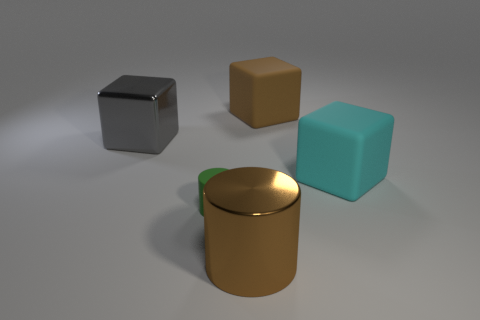Add 1 big rubber cubes. How many objects exist? 6 Subtract all blocks. How many objects are left? 2 Add 2 big metal blocks. How many big metal blocks are left? 3 Add 2 purple metal cylinders. How many purple metal cylinders exist? 2 Subtract 0 yellow cubes. How many objects are left? 5 Subtract all brown matte cubes. Subtract all green matte cylinders. How many objects are left? 3 